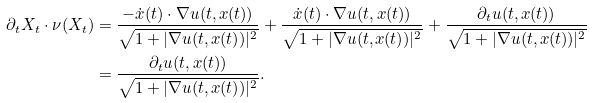Convert formula to latex. <formula><loc_0><loc_0><loc_500><loc_500>\partial _ { t } X _ { t } \cdot \nu ( X _ { t } ) & = \frac { - \dot { x } ( t ) \cdot \nabla u ( t , x ( t ) ) } { \sqrt { 1 + | \nabla u ( t , x ( t ) ) | ^ { 2 } } } + \frac { \dot { x } ( t ) \cdot \nabla u ( t , x ( t ) ) } { \sqrt { 1 + | \nabla u ( t , x ( t ) ) | ^ { 2 } } } + \frac { \partial _ { t } u ( t , x ( t ) ) } { \sqrt { 1 + | \nabla u ( t , x ( t ) ) | ^ { 2 } } } \\ & = \frac { \partial _ { t } u ( t , x ( t ) ) } { \sqrt { 1 + | \nabla u ( t , x ( t ) ) | ^ { 2 } } } .</formula> 